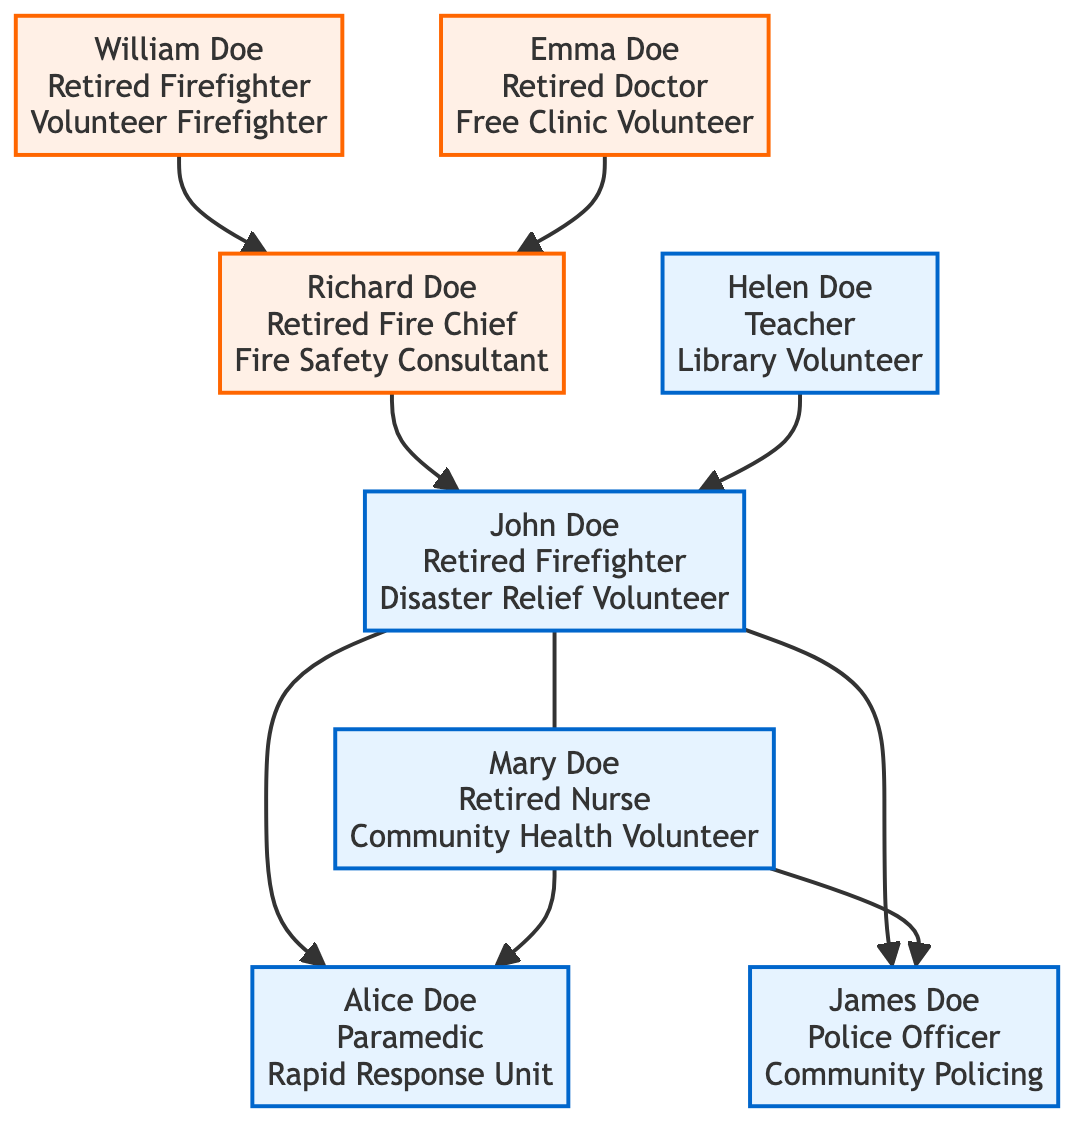What is the full name of the proband? The proband is identified at the top of the family tree, denoting the primary individual for whom the tree is constructed. Looking directly, the name displayed is "John Doe."
Answer: John Doe How many children does John Doe have? The children are listed under the proband's name in the family tree. Counting the names displayed beneath John Doe, there are two children: Alice Doe and James Doe.
Answer: 2 What is the current activity of Mary Doe? Mary Doe is listed as the spouse of John Doe. Her current activity is specified next to her name in the diagram, which states "Community Health Volunteer."
Answer: Community Health Volunteer Who are the grandparents of Alice Doe? Alice Doe is one of the children of John and Mary Doe. To find her grandparents, we look at the layer above her parents. The grandparents listed are William Doe and Emma Doe.
Answer: William Doe and Emma Doe What is the role of Richard Doe? Richard Doe appears as John Doe's father in the diagram. His role is mentioned directly under his name, which is "Fire Chief (Retired)."
Answer: Fire Chief (Retired) Which child is a Police Officer? The children of John and Mary Doe are displayed below their names. Among the children, James Doe is explicitly noted as a Police Officer.
Answer: James Doe What is the relationship between John Doe and Richard Doe? John Doe and Richard Doe are positioned such that Richard sits in the parent node above John, indicating that Richard is John's father.
Answer: Father How many retired individuals are there in the family tree? Looking at the roles mentioned, the retired individuals are William Doe, Emma Doe, Richard Doe, and John Doe. Counting these roles shows a total of four retired individuals in the family tree.
Answer: 4 What is the current role of Alice Doe? Alice Doe's role can be seen directly underneath her name in the diagram. It states that she is a "Paramedic," detailing her professional affiliation.
Answer: Paramedic What is the current activity of William Doe? William Doe is situated at the top layer of the tree. His current activity, as specified next to his name, indicates that he is a "Volunteer Firefighter."
Answer: Volunteer Firefighter 